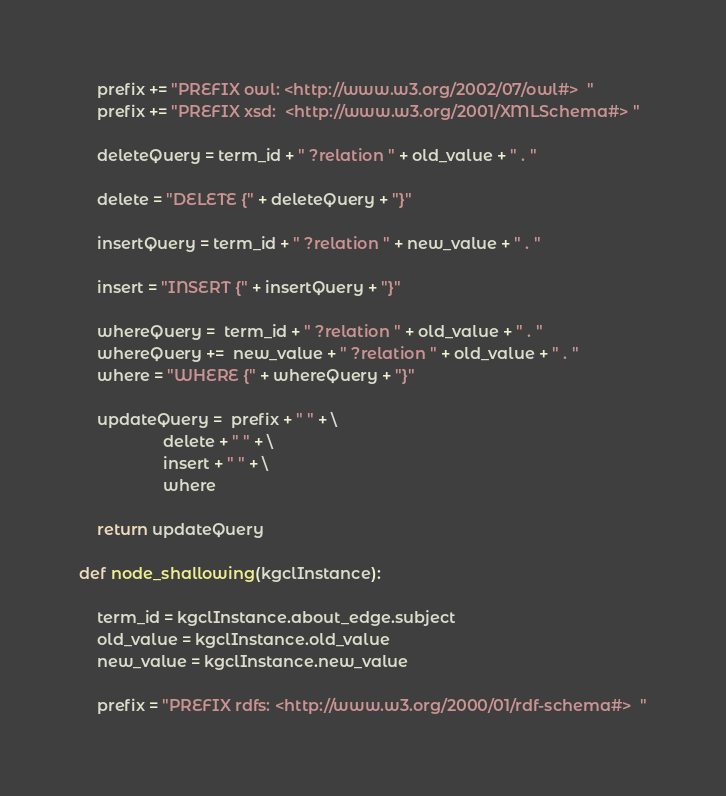<code> <loc_0><loc_0><loc_500><loc_500><_Python_>    prefix += "PREFIX owl: <http://www.w3.org/2002/07/owl#>  "
    prefix += "PREFIX xsd:  <http://www.w3.org/2001/XMLSchema#> " 

    deleteQuery = term_id + " ?relation " + old_value + " . " 

    delete = "DELETE {" + deleteQuery + "}"

    insertQuery = term_id + " ?relation " + new_value + " . " 

    insert = "INSERT {" + insertQuery + "}" 

    whereQuery =  term_id + " ?relation " + old_value + " . " 
    whereQuery +=  new_value + " ?relation " + old_value + " . " 
    where = "WHERE {" + whereQuery + "}"

    updateQuery =  prefix + " " + \
                   delete + " " + \
                   insert + " " + \
                   where

    return updateQuery 

def node_shallowing(kgclInstance):
    
    term_id = kgclInstance.about_edge.subject
    old_value = kgclInstance.old_value
    new_value = kgclInstance.new_value

    prefix = "PREFIX rdfs: <http://www.w3.org/2000/01/rdf-schema#>  "</code> 